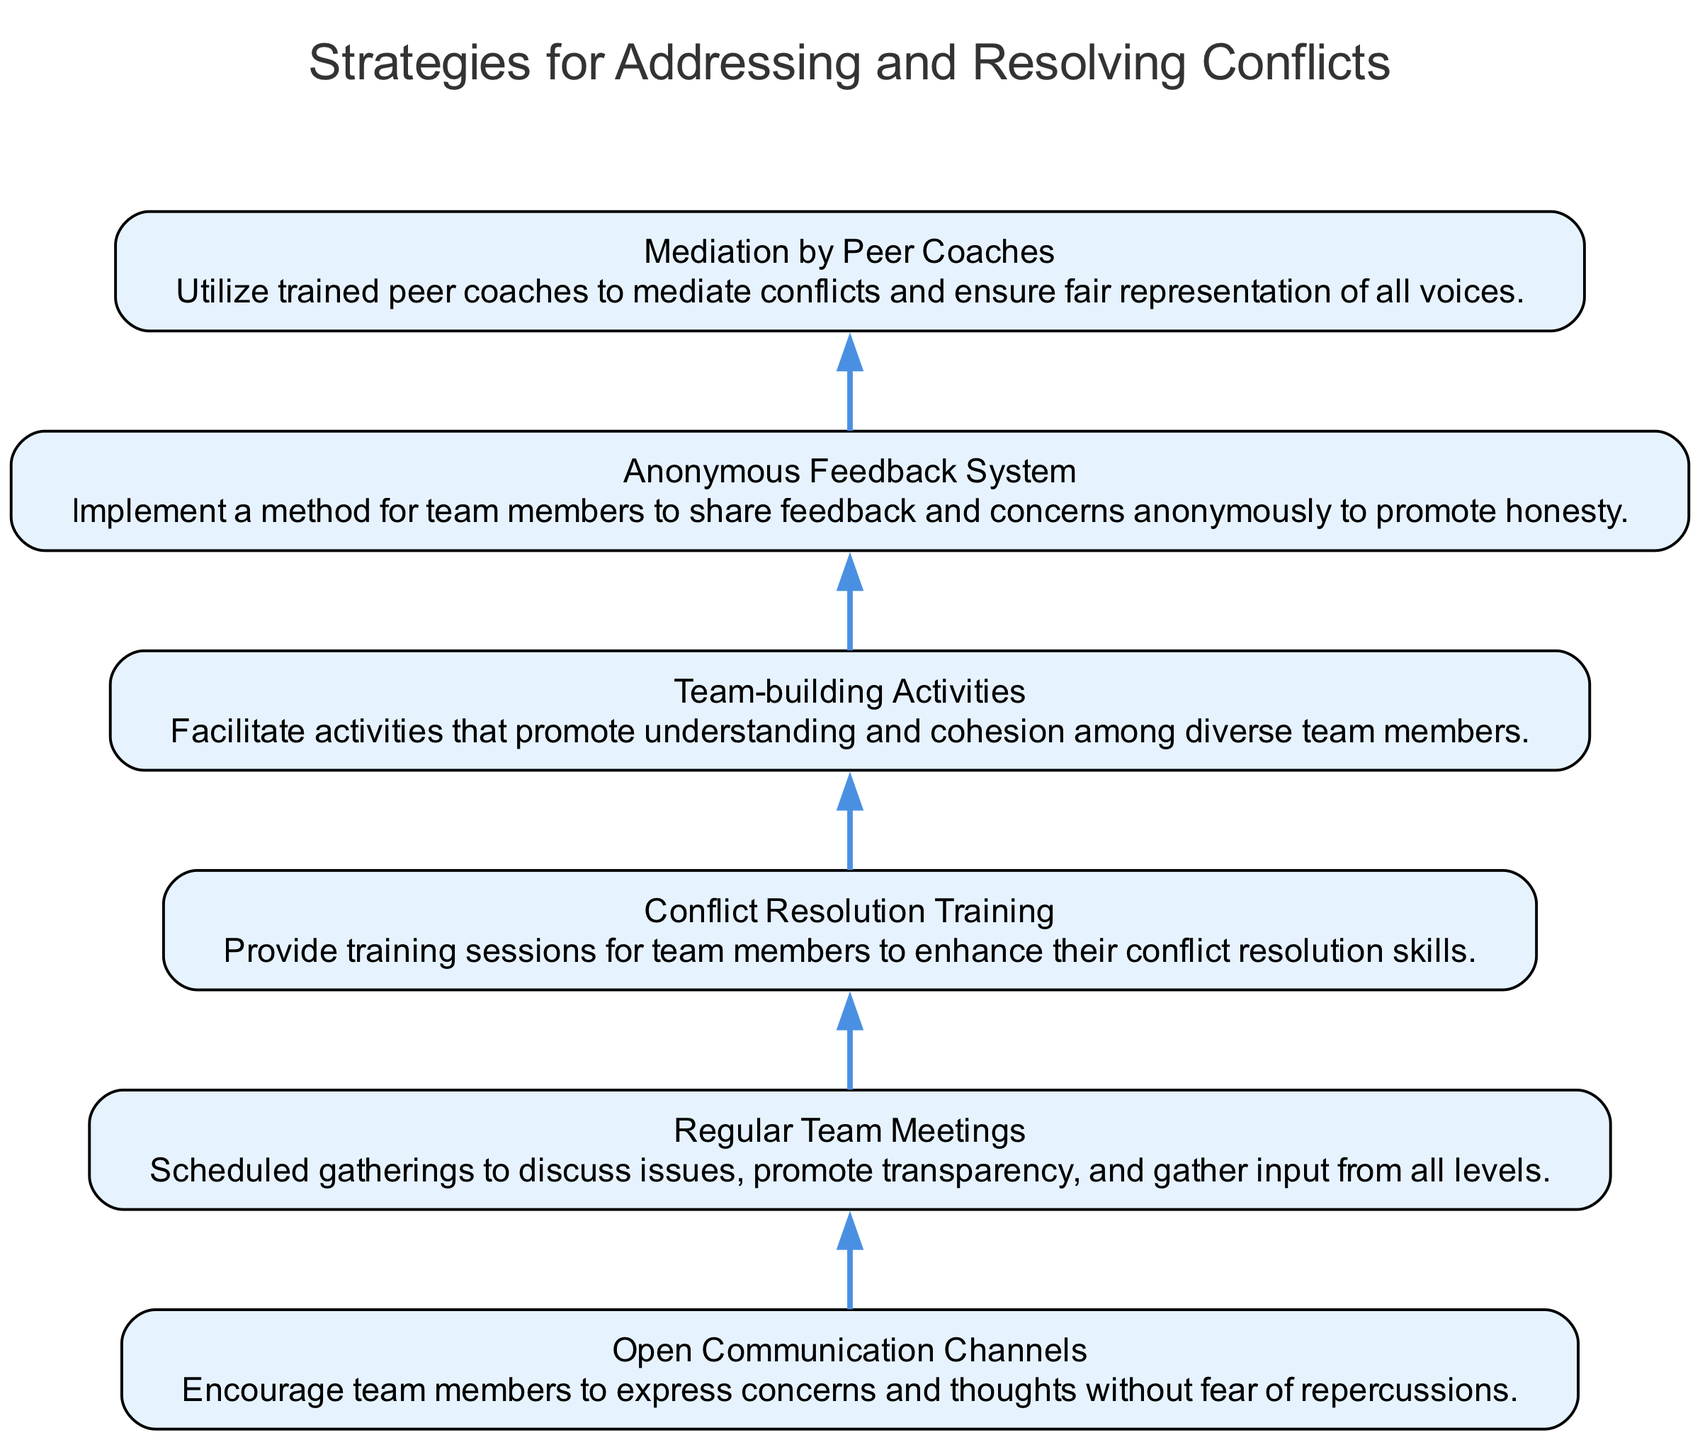What is the first strategy listed in the diagram? The first strategy in the flow chart is "Open Communication Channels." It is the first element added to the graph, indicating its position at the bottom and starting point of the flow.
Answer: Open Communication Channels How many strategies are included in the diagram? The diagram displays a total of six distinct strategies. Each strategy corresponds to an individual node in the flow chart.
Answer: Six What is the last strategy mentioned in the flow chart? The last strategy in the flow chart is "Mediation by Peer Coaches." It is the final node at the top of the diagram, representing the culmination of the strategies.
Answer: Mediation by Peer Coaches Which strategy is directly above "Conflict Resolution Training"? "Regular Team Meetings" is the strategy that is located directly above "Conflict Resolution Training" in the flow chart. This indicates it precedes the conflict training in the sequence.
Answer: Regular Team Meetings What role does the "Anonymous Feedback System" play in the diagram? The "Anonymous Feedback System" is one of the strategies aimed at addressing team conflicts by allowing members to express their concerns without revealing their identity, promoting honesty and transparency.
Answer: Promotes honesty What relationship exists between "Team-building Activities" and "Conflict Resolution Training"? "Team-building Activities" is located below "Conflict Resolution Training," which suggests that team-building can support conflict training by fostering better relationships and understanding among team members.
Answer: Supporting relationship Which two strategies are connected by the same edge directly? "Regular Team Meetings" and "Conflict Resolution Training" are two strategies that are directly connected by the edge, indicating they follow one another in the flow of addressing conflicts.
Answer: Regular Team Meetings and Conflict Resolution Training What type of feedback does the "Anonymous Feedback System" encourage? The "Anonymous Feedback System" encourages honest feedback from team members regarding their issues, as it allows them to express concerns without fear of being identified.
Answer: Honest feedback In what way do "Mediation by Peer Coaches" and "Team-building Activities" interact in this flow? "Mediation by Peer Coaches" follows "Team-building Activities" in the flow chart, indicating that the foundational work done in team-building may facilitate better mediation processes among team members during conflicts.
Answer: Facilitate better mediation 